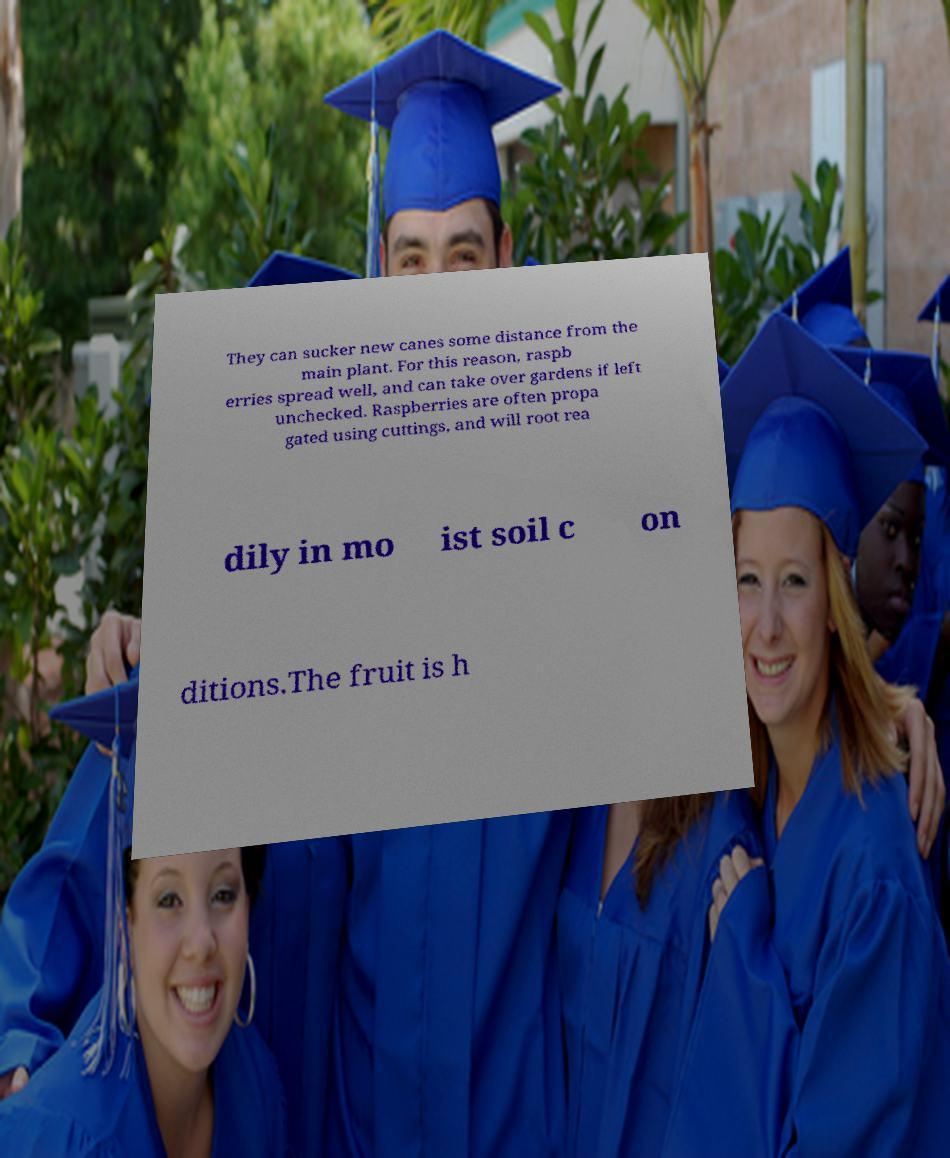Can you read and provide the text displayed in the image?This photo seems to have some interesting text. Can you extract and type it out for me? They can sucker new canes some distance from the main plant. For this reason, raspb erries spread well, and can take over gardens if left unchecked. Raspberries are often propa gated using cuttings, and will root rea dily in mo ist soil c on ditions.The fruit is h 